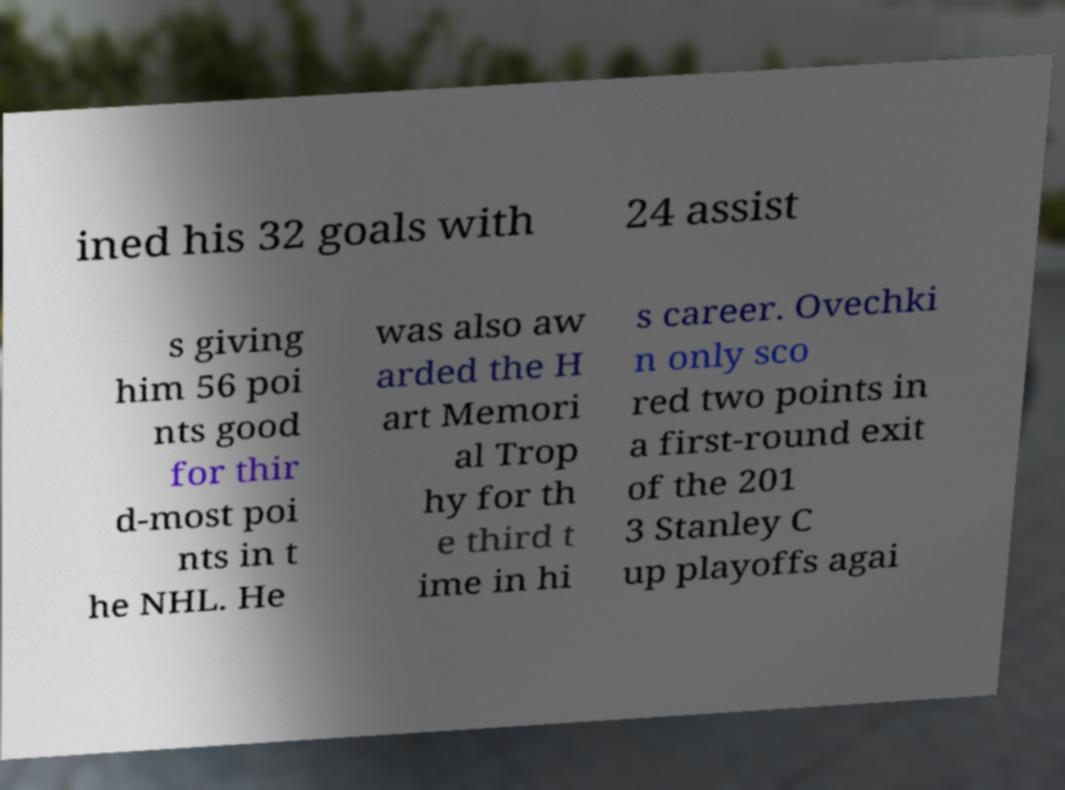What messages or text are displayed in this image? I need them in a readable, typed format. ined his 32 goals with 24 assist s giving him 56 poi nts good for thir d-most poi nts in t he NHL. He was also aw arded the H art Memori al Trop hy for th e third t ime in hi s career. Ovechki n only sco red two points in a first-round exit of the 201 3 Stanley C up playoffs agai 